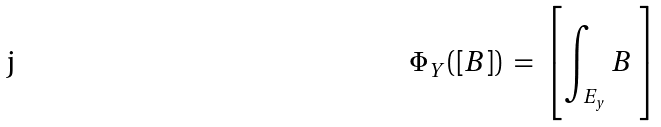Convert formula to latex. <formula><loc_0><loc_0><loc_500><loc_500>\Phi _ { Y } ( [ B ] ) \ = \ \left [ \int _ { E _ { y } } B \ \right ]</formula> 